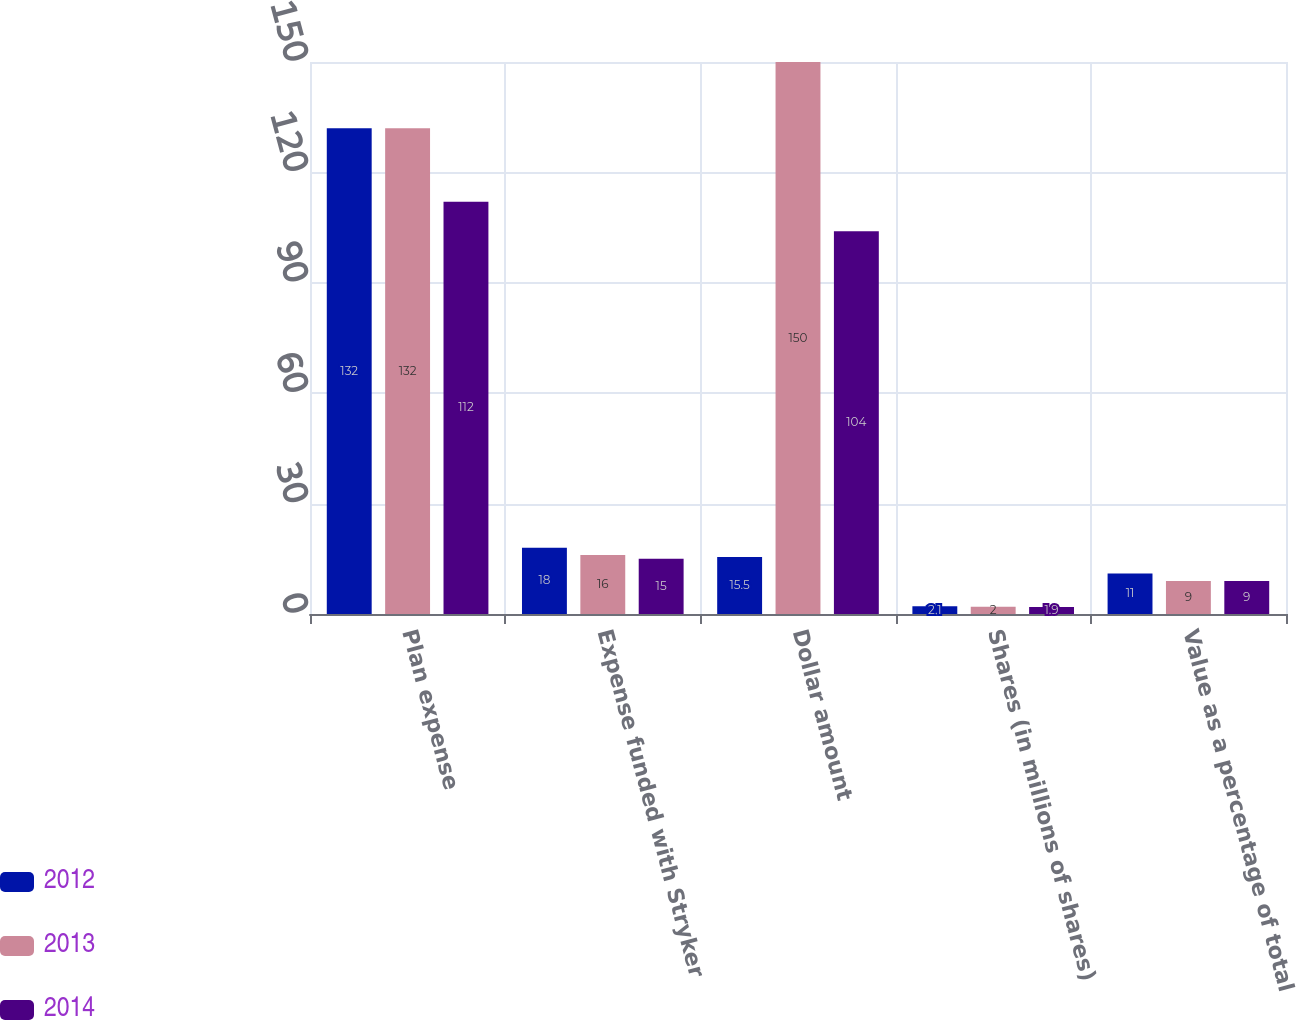<chart> <loc_0><loc_0><loc_500><loc_500><stacked_bar_chart><ecel><fcel>Plan expense<fcel>Expense funded with Stryker<fcel>Dollar amount<fcel>Shares (in millions of shares)<fcel>Value as a percentage of total<nl><fcel>2012<fcel>132<fcel>18<fcel>15.5<fcel>2.1<fcel>11<nl><fcel>2013<fcel>132<fcel>16<fcel>150<fcel>2<fcel>9<nl><fcel>2014<fcel>112<fcel>15<fcel>104<fcel>1.9<fcel>9<nl></chart> 